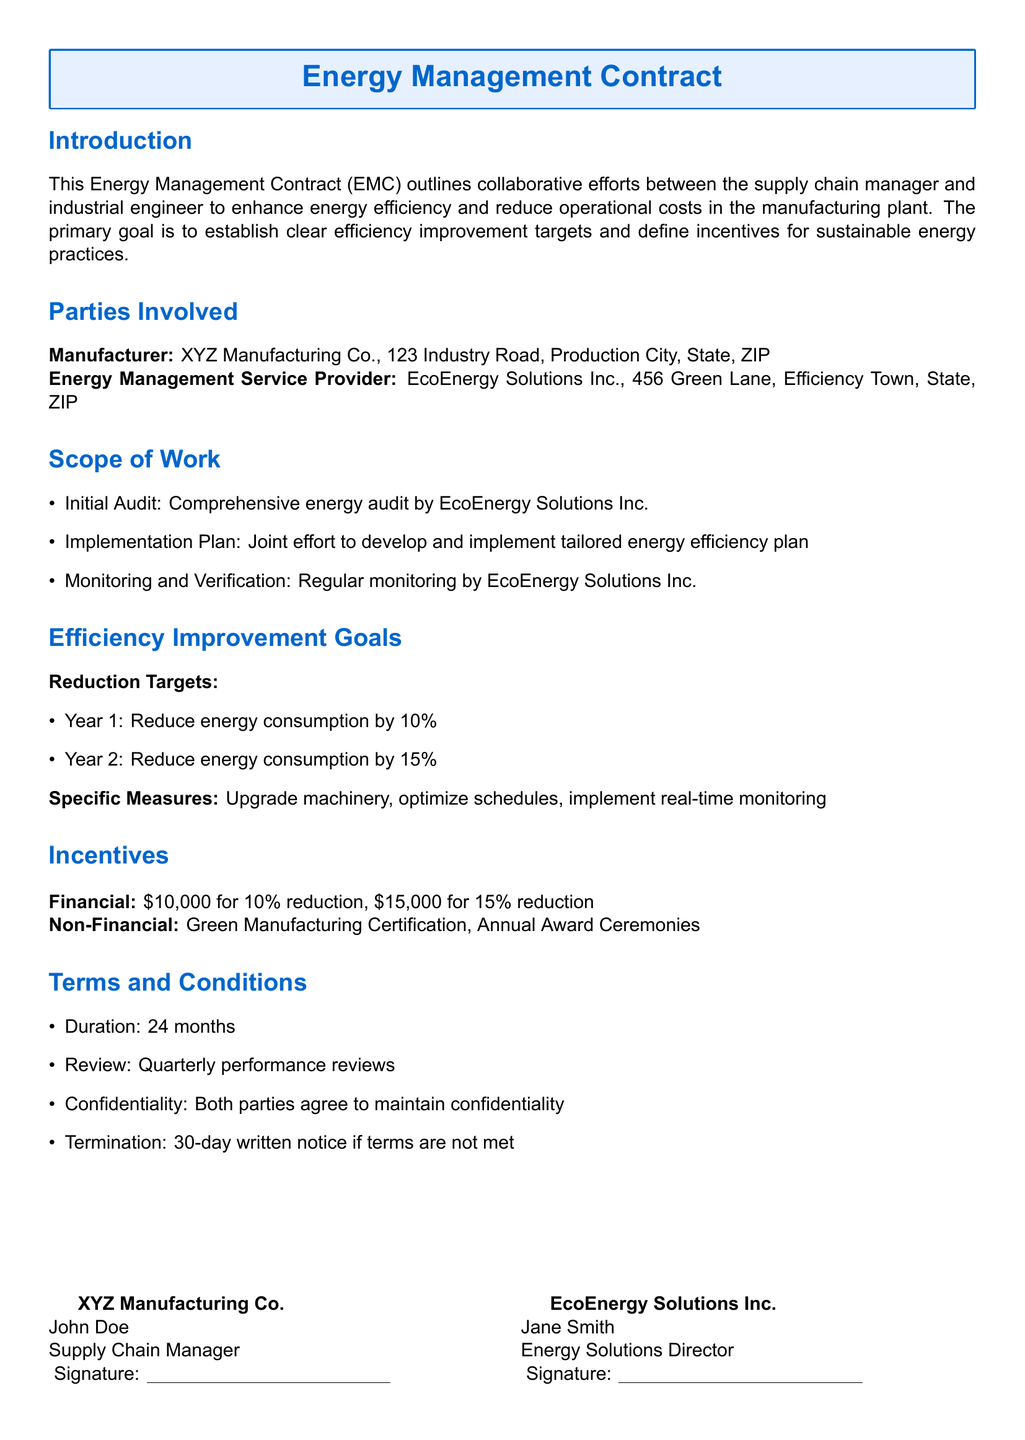What is the duration of the contract? The document states the duration in the Terms and Conditions section.
Answer: 24 months Who is the Energy Solutions Director? The document lists Jane Smith as the contact person for EcoEnergy Solutions Inc.
Answer: Jane Smith What is the targeted reduction in energy consumption for Year 2? The Efficiency Improvement Goals section provides this information.
Answer: 15% What are the financial incentives for achieving the Year 1 reduction target? The Incentives section outlines the financial rewards associated with the targets.
Answer: $10,000 How often will performance reviews be conducted? The Terms and Conditions section specifies the frequency of reviews.
Answer: Quarterly What is the purpose of the initial audit? The Scope of Work section details the purpose of the initial audit mentioned.
Answer: Comprehensive energy audit What certification can be obtained through non-financial incentives? The document states this in the Incentives section.
Answer: Green Manufacturing Certification What must happen for either party to terminate the contract? The document outlines the conditions under which the contract can be terminated in the Terms and Conditions.
Answer: 30-day written notice if terms are not met What is the complete address of the Manufacturer? The Parties Involved section contains this information.
Answer: 123 Industry Road, Production City, State, ZIP 